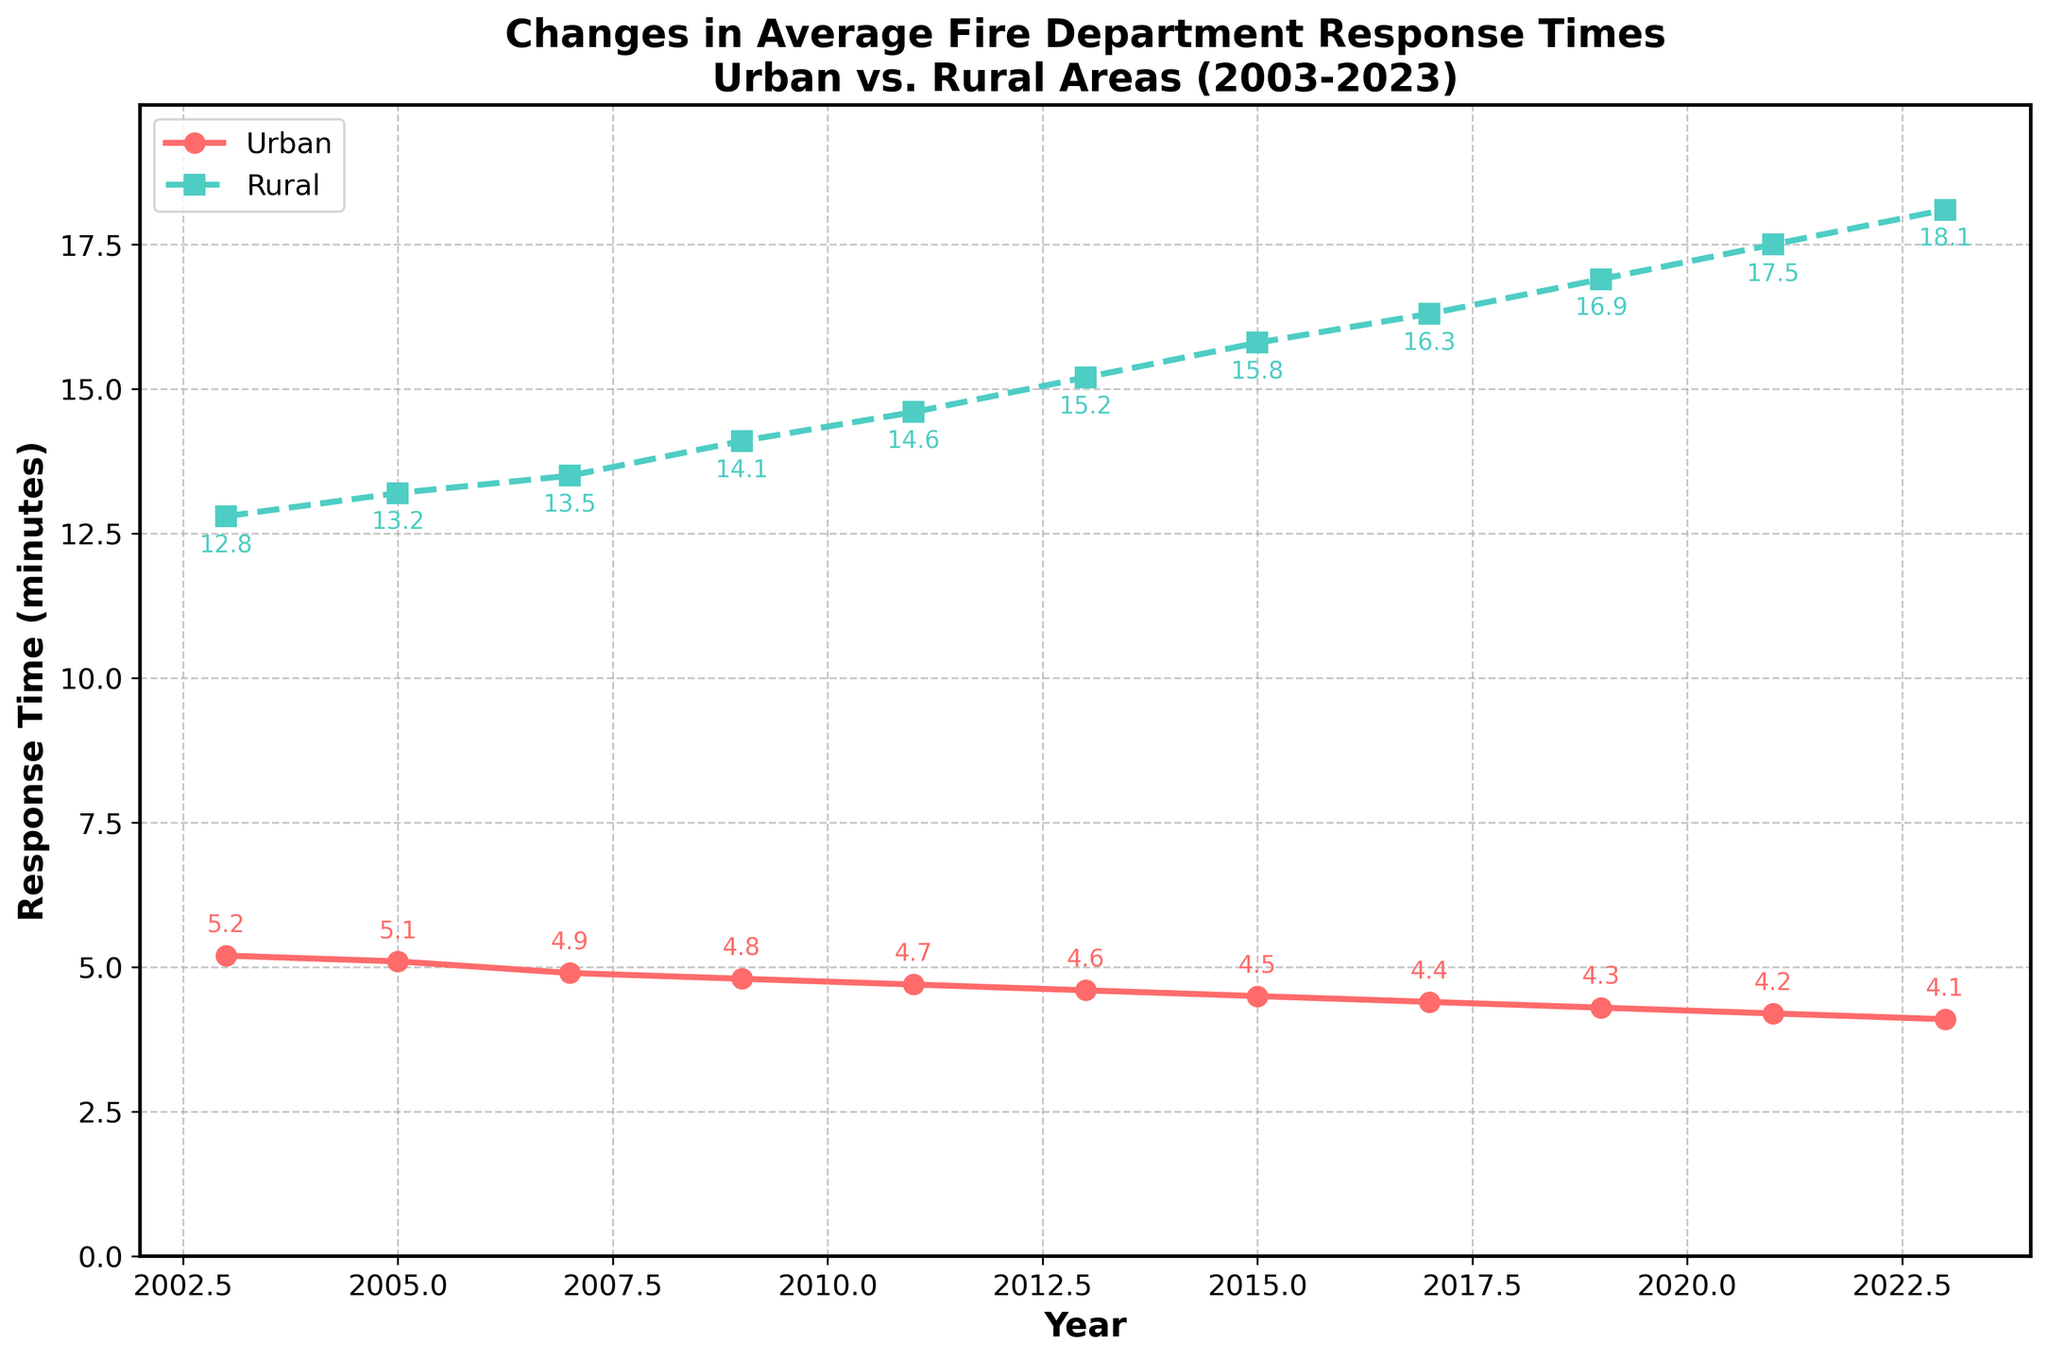What is the trend for urban response times over the years? Urban response times have consistently decreased from 5.2 minutes in 2003 to 4.1 minutes in 2023. To observe this trend, look at the line labeled "Urban", which shows a downward trajectory.
Answer: Decreased How does the change in rural response times compare to the change in urban response times from 2003 to 2023? Urban response times decreased from 5.2 minutes to 4.1 minutes, a drop of 1.1 minutes. Rural response times increased from 12.8 minutes to 18.1 minutes, an increase of 5.3 minutes. Comparing these values shows different trends, with urban times decreasing and rural times increasing.
Answer: Urban decreased, Rural increased By how many minutes did the rural response times increase between 2009 and 2023? The rural response times in 2009 were 14.1 minutes, and in 2023 they were 18.1 minutes. The increase is calculated as 18.1 - 14.1 = 4.0 minutes.
Answer: 4.0 minutes Which year shows the smallest gap between urban and rural response times? To find the smallest gap, we must subtract the urban response time from the rural response time for each year. The smallest gap is in 2003, where the gap is 12.8 - 5.2 = 7.6 minutes.
Answer: 2003 In what year did urban response times drop below 5 minutes for the first time? Checking the urban response times for each year, we see that in 2007, the urban response time was 4.9 minutes, marking the first year it dropped below 5 minutes.
Answer: 2007 In which years did urban response times drop by 0.1 minutes successively? The urban response times decreased by 0.1 minutes successively in the years 2009 (4.8 minutes), 2011 (4.7 minutes), and 2013 (4.6 minutes).
Answer: 2009, 2011, 2013 What was the percentage increase in rural response times from 2005 to 2023? The rural response times increased from 13.2 minutes in 2005 to 18.1 minutes in 2023. The percentage increase is calculated as ((18.1 - 13.2) / 13.2) * 100 = 37.12%.
Answer: 37.12% Was there any year in which both urban and rural response times either increased or decreased together compared to the previous year? No, in each observed transition year, when urban response times decreased, rural response times increased, and vice versa.
Answer: No What is the difference in urban and rural response times in 2023? In 2023, urban response times were 4.1 minutes, and rural response times were 18.1 minutes. The difference is 18.1 - 4.1 = 14.0 minutes.
Answer: 14.0 minutes By how much did the urban response times improve between 2003 and 2013? In 2003, the urban response time was 5.2 minutes, and in 2013 it was 4.6 minutes. The improvement is calculated as 5.2 - 4.6 = 0.6 minutes.
Answer: 0.6 minutes 